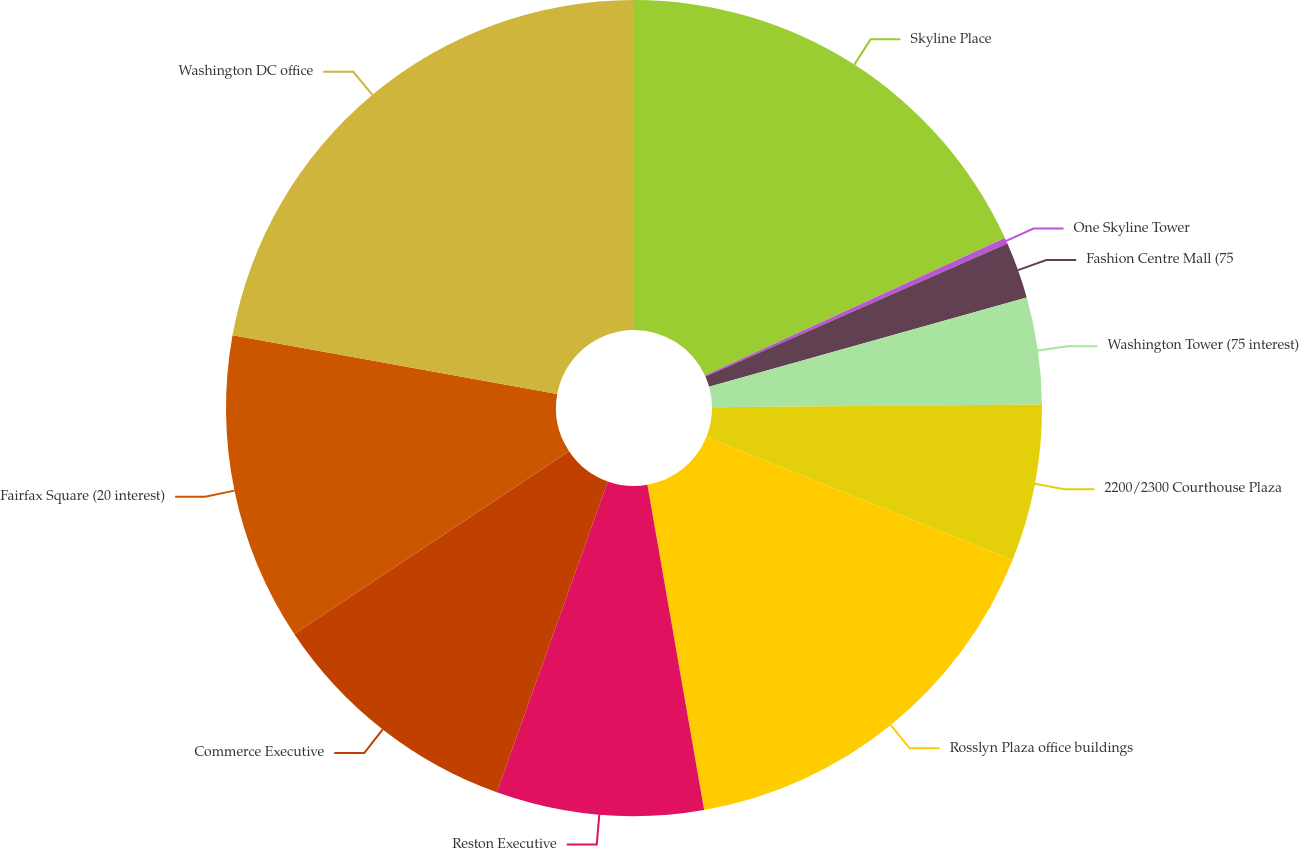<chart> <loc_0><loc_0><loc_500><loc_500><pie_chart><fcel>Skyline Place<fcel>One Skyline Tower<fcel>Fashion Centre Mall (75<fcel>Washington Tower (75 interest)<fcel>2200/2300 Courthouse Plaza<fcel>Rosslyn Plaza office buildings<fcel>Reston Executive<fcel>Commerce Executive<fcel>Fairfax Square (20 interest)<fcel>Washington DC office<nl><fcel>18.16%<fcel>0.24%<fcel>2.23%<fcel>4.23%<fcel>6.22%<fcel>16.17%<fcel>8.21%<fcel>10.2%<fcel>12.19%<fcel>22.15%<nl></chart> 